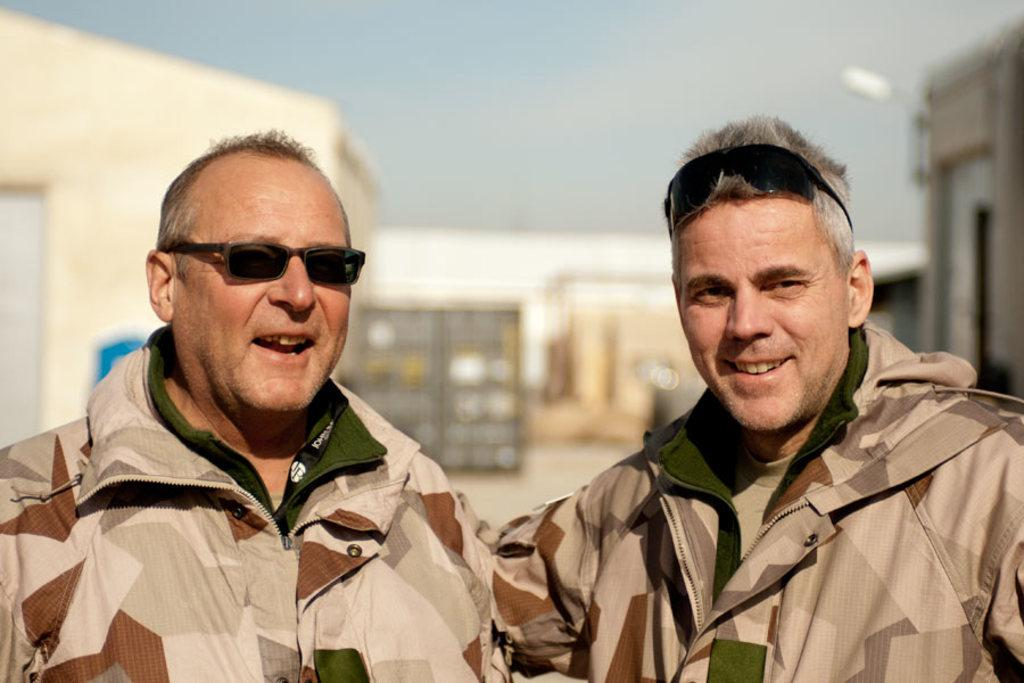How many people are in the image? There are two men in the image. What are the men wearing? The men are wearing uniforms and black color goggles. What is the facial expression of the men in the image? The men are smiling. What can be seen in the background of the image? There are buildings in the background of the image. What is visible at the top of the image? The sky is visible at the top of the image. What type of wine is being served by the band in the image? There is no band or wine present in the image; it features two men wearing uniforms and goggles. How does the match between the two teams affect the men in the image? There is no match or teams mentioned in the image; it only shows two men smiling. 